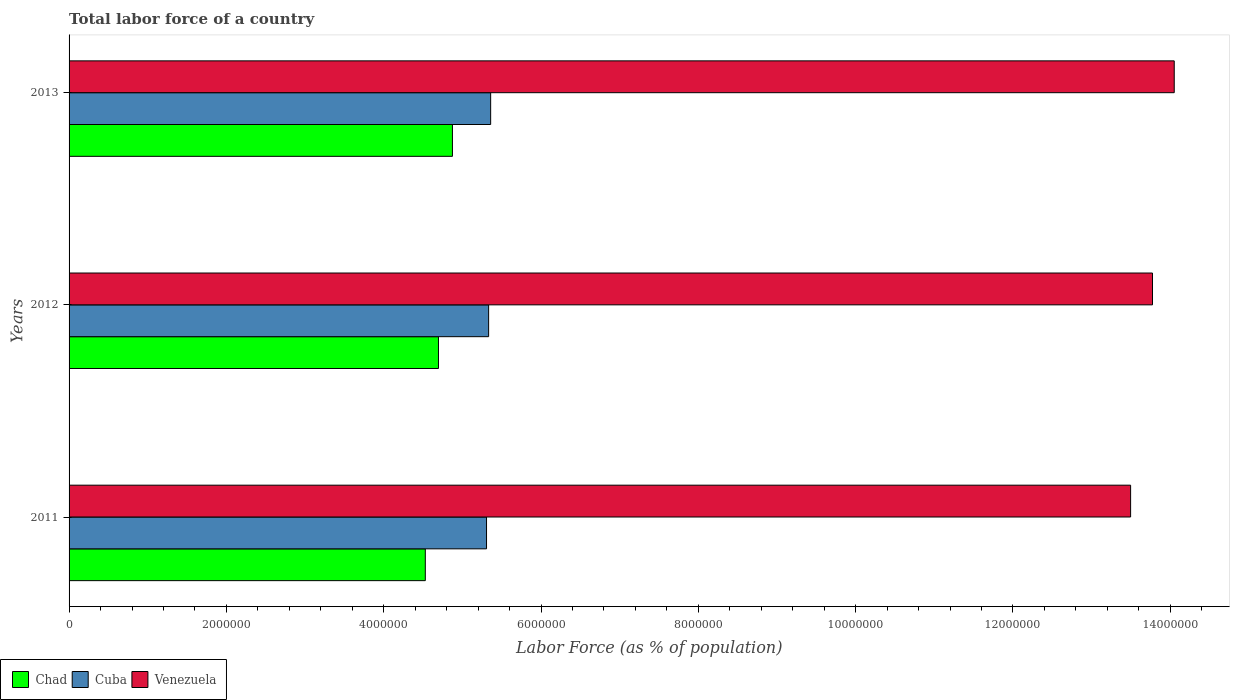How many different coloured bars are there?
Your answer should be very brief. 3. Are the number of bars per tick equal to the number of legend labels?
Your answer should be compact. Yes. How many bars are there on the 1st tick from the top?
Provide a succinct answer. 3. How many bars are there on the 2nd tick from the bottom?
Offer a terse response. 3. What is the label of the 1st group of bars from the top?
Your answer should be very brief. 2013. What is the percentage of labor force in Chad in 2012?
Offer a very short reply. 4.70e+06. Across all years, what is the maximum percentage of labor force in Chad?
Offer a terse response. 4.87e+06. Across all years, what is the minimum percentage of labor force in Chad?
Provide a succinct answer. 4.53e+06. In which year was the percentage of labor force in Venezuela minimum?
Offer a terse response. 2011. What is the total percentage of labor force in Cuba in the graph?
Make the answer very short. 1.60e+07. What is the difference between the percentage of labor force in Chad in 2011 and that in 2012?
Make the answer very short. -1.67e+05. What is the difference between the percentage of labor force in Cuba in 2011 and the percentage of labor force in Chad in 2012?
Your answer should be very brief. 6.11e+05. What is the average percentage of labor force in Chad per year?
Provide a succinct answer. 4.70e+06. In the year 2012, what is the difference between the percentage of labor force in Chad and percentage of labor force in Cuba?
Ensure brevity in your answer.  -6.38e+05. In how many years, is the percentage of labor force in Venezuela greater than 3600000 %?
Make the answer very short. 3. What is the ratio of the percentage of labor force in Venezuela in 2011 to that in 2012?
Your answer should be compact. 0.98. Is the difference between the percentage of labor force in Chad in 2011 and 2013 greater than the difference between the percentage of labor force in Cuba in 2011 and 2013?
Offer a very short reply. No. What is the difference between the highest and the second highest percentage of labor force in Venezuela?
Your answer should be very brief. 2.76e+05. What is the difference between the highest and the lowest percentage of labor force in Chad?
Give a very brief answer. 3.45e+05. In how many years, is the percentage of labor force in Venezuela greater than the average percentage of labor force in Venezuela taken over all years?
Offer a terse response. 2. Is the sum of the percentage of labor force in Cuba in 2012 and 2013 greater than the maximum percentage of labor force in Chad across all years?
Give a very brief answer. Yes. What does the 1st bar from the top in 2013 represents?
Ensure brevity in your answer.  Venezuela. What does the 2nd bar from the bottom in 2013 represents?
Provide a short and direct response. Cuba. Is it the case that in every year, the sum of the percentage of labor force in Venezuela and percentage of labor force in Cuba is greater than the percentage of labor force in Chad?
Ensure brevity in your answer.  Yes. How many bars are there?
Your answer should be compact. 9. What is the difference between two consecutive major ticks on the X-axis?
Offer a very short reply. 2.00e+06. Does the graph contain any zero values?
Provide a short and direct response. No. Does the graph contain grids?
Your response must be concise. No. Where does the legend appear in the graph?
Give a very brief answer. Bottom left. How many legend labels are there?
Keep it short and to the point. 3. How are the legend labels stacked?
Your answer should be compact. Horizontal. What is the title of the graph?
Your response must be concise. Total labor force of a country. What is the label or title of the X-axis?
Your answer should be very brief. Labor Force (as % of population). What is the label or title of the Y-axis?
Ensure brevity in your answer.  Years. What is the Labor Force (as % of population) in Chad in 2011?
Ensure brevity in your answer.  4.53e+06. What is the Labor Force (as % of population) of Cuba in 2011?
Make the answer very short. 5.31e+06. What is the Labor Force (as % of population) of Venezuela in 2011?
Provide a short and direct response. 1.35e+07. What is the Labor Force (as % of population) in Chad in 2012?
Give a very brief answer. 4.70e+06. What is the Labor Force (as % of population) of Cuba in 2012?
Your response must be concise. 5.33e+06. What is the Labor Force (as % of population) of Venezuela in 2012?
Make the answer very short. 1.38e+07. What is the Labor Force (as % of population) in Chad in 2013?
Offer a terse response. 4.87e+06. What is the Labor Force (as % of population) of Cuba in 2013?
Your response must be concise. 5.36e+06. What is the Labor Force (as % of population) of Venezuela in 2013?
Your response must be concise. 1.41e+07. Across all years, what is the maximum Labor Force (as % of population) in Chad?
Your response must be concise. 4.87e+06. Across all years, what is the maximum Labor Force (as % of population) of Cuba?
Your answer should be very brief. 5.36e+06. Across all years, what is the maximum Labor Force (as % of population) of Venezuela?
Your answer should be compact. 1.41e+07. Across all years, what is the minimum Labor Force (as % of population) of Chad?
Offer a terse response. 4.53e+06. Across all years, what is the minimum Labor Force (as % of population) in Cuba?
Provide a succinct answer. 5.31e+06. Across all years, what is the minimum Labor Force (as % of population) of Venezuela?
Offer a terse response. 1.35e+07. What is the total Labor Force (as % of population) in Chad in the graph?
Your answer should be compact. 1.41e+07. What is the total Labor Force (as % of population) of Cuba in the graph?
Make the answer very short. 1.60e+07. What is the total Labor Force (as % of population) in Venezuela in the graph?
Keep it short and to the point. 4.13e+07. What is the difference between the Labor Force (as % of population) in Chad in 2011 and that in 2012?
Offer a terse response. -1.67e+05. What is the difference between the Labor Force (as % of population) of Cuba in 2011 and that in 2012?
Make the answer very short. -2.65e+04. What is the difference between the Labor Force (as % of population) of Venezuela in 2011 and that in 2012?
Make the answer very short. -2.78e+05. What is the difference between the Labor Force (as % of population) of Chad in 2011 and that in 2013?
Provide a short and direct response. -3.45e+05. What is the difference between the Labor Force (as % of population) of Cuba in 2011 and that in 2013?
Your answer should be compact. -5.23e+04. What is the difference between the Labor Force (as % of population) in Venezuela in 2011 and that in 2013?
Give a very brief answer. -5.55e+05. What is the difference between the Labor Force (as % of population) in Chad in 2012 and that in 2013?
Your response must be concise. -1.78e+05. What is the difference between the Labor Force (as % of population) of Cuba in 2012 and that in 2013?
Offer a very short reply. -2.58e+04. What is the difference between the Labor Force (as % of population) of Venezuela in 2012 and that in 2013?
Your response must be concise. -2.76e+05. What is the difference between the Labor Force (as % of population) in Chad in 2011 and the Labor Force (as % of population) in Cuba in 2012?
Offer a terse response. -8.05e+05. What is the difference between the Labor Force (as % of population) in Chad in 2011 and the Labor Force (as % of population) in Venezuela in 2012?
Keep it short and to the point. -9.24e+06. What is the difference between the Labor Force (as % of population) of Cuba in 2011 and the Labor Force (as % of population) of Venezuela in 2012?
Ensure brevity in your answer.  -8.47e+06. What is the difference between the Labor Force (as % of population) in Chad in 2011 and the Labor Force (as % of population) in Cuba in 2013?
Your answer should be very brief. -8.31e+05. What is the difference between the Labor Force (as % of population) in Chad in 2011 and the Labor Force (as % of population) in Venezuela in 2013?
Your response must be concise. -9.52e+06. What is the difference between the Labor Force (as % of population) in Cuba in 2011 and the Labor Force (as % of population) in Venezuela in 2013?
Offer a terse response. -8.74e+06. What is the difference between the Labor Force (as % of population) of Chad in 2012 and the Labor Force (as % of population) of Cuba in 2013?
Offer a very short reply. -6.63e+05. What is the difference between the Labor Force (as % of population) of Chad in 2012 and the Labor Force (as % of population) of Venezuela in 2013?
Make the answer very short. -9.35e+06. What is the difference between the Labor Force (as % of population) in Cuba in 2012 and the Labor Force (as % of population) in Venezuela in 2013?
Ensure brevity in your answer.  -8.72e+06. What is the average Labor Force (as % of population) in Chad per year?
Ensure brevity in your answer.  4.70e+06. What is the average Labor Force (as % of population) of Cuba per year?
Give a very brief answer. 5.33e+06. What is the average Labor Force (as % of population) of Venezuela per year?
Offer a very short reply. 1.38e+07. In the year 2011, what is the difference between the Labor Force (as % of population) of Chad and Labor Force (as % of population) of Cuba?
Provide a succinct answer. -7.78e+05. In the year 2011, what is the difference between the Labor Force (as % of population) of Chad and Labor Force (as % of population) of Venezuela?
Ensure brevity in your answer.  -8.97e+06. In the year 2011, what is the difference between the Labor Force (as % of population) of Cuba and Labor Force (as % of population) of Venezuela?
Provide a succinct answer. -8.19e+06. In the year 2012, what is the difference between the Labor Force (as % of population) of Chad and Labor Force (as % of population) of Cuba?
Make the answer very short. -6.38e+05. In the year 2012, what is the difference between the Labor Force (as % of population) in Chad and Labor Force (as % of population) in Venezuela?
Provide a succinct answer. -9.08e+06. In the year 2012, what is the difference between the Labor Force (as % of population) of Cuba and Labor Force (as % of population) of Venezuela?
Offer a terse response. -8.44e+06. In the year 2013, what is the difference between the Labor Force (as % of population) in Chad and Labor Force (as % of population) in Cuba?
Make the answer very short. -4.86e+05. In the year 2013, what is the difference between the Labor Force (as % of population) in Chad and Labor Force (as % of population) in Venezuela?
Ensure brevity in your answer.  -9.18e+06. In the year 2013, what is the difference between the Labor Force (as % of population) of Cuba and Labor Force (as % of population) of Venezuela?
Your response must be concise. -8.69e+06. What is the ratio of the Labor Force (as % of population) in Chad in 2011 to that in 2012?
Keep it short and to the point. 0.96. What is the ratio of the Labor Force (as % of population) of Venezuela in 2011 to that in 2012?
Provide a short and direct response. 0.98. What is the ratio of the Labor Force (as % of population) of Chad in 2011 to that in 2013?
Your answer should be very brief. 0.93. What is the ratio of the Labor Force (as % of population) of Cuba in 2011 to that in 2013?
Your answer should be compact. 0.99. What is the ratio of the Labor Force (as % of population) in Venezuela in 2011 to that in 2013?
Offer a terse response. 0.96. What is the ratio of the Labor Force (as % of population) in Chad in 2012 to that in 2013?
Your answer should be very brief. 0.96. What is the ratio of the Labor Force (as % of population) of Cuba in 2012 to that in 2013?
Provide a short and direct response. 1. What is the ratio of the Labor Force (as % of population) in Venezuela in 2012 to that in 2013?
Make the answer very short. 0.98. What is the difference between the highest and the second highest Labor Force (as % of population) in Chad?
Ensure brevity in your answer.  1.78e+05. What is the difference between the highest and the second highest Labor Force (as % of population) of Cuba?
Offer a terse response. 2.58e+04. What is the difference between the highest and the second highest Labor Force (as % of population) in Venezuela?
Your answer should be compact. 2.76e+05. What is the difference between the highest and the lowest Labor Force (as % of population) in Chad?
Keep it short and to the point. 3.45e+05. What is the difference between the highest and the lowest Labor Force (as % of population) of Cuba?
Your response must be concise. 5.23e+04. What is the difference between the highest and the lowest Labor Force (as % of population) in Venezuela?
Make the answer very short. 5.55e+05. 